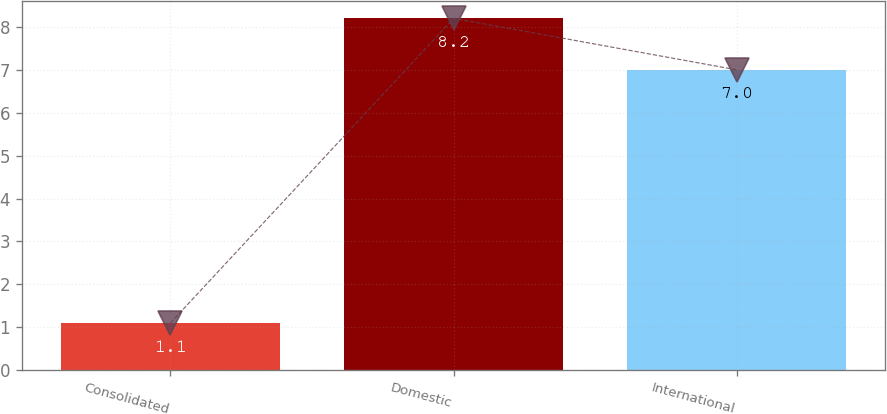Convert chart to OTSL. <chart><loc_0><loc_0><loc_500><loc_500><bar_chart><fcel>Consolidated<fcel>Domestic<fcel>International<nl><fcel>1.1<fcel>8.2<fcel>7<nl></chart> 